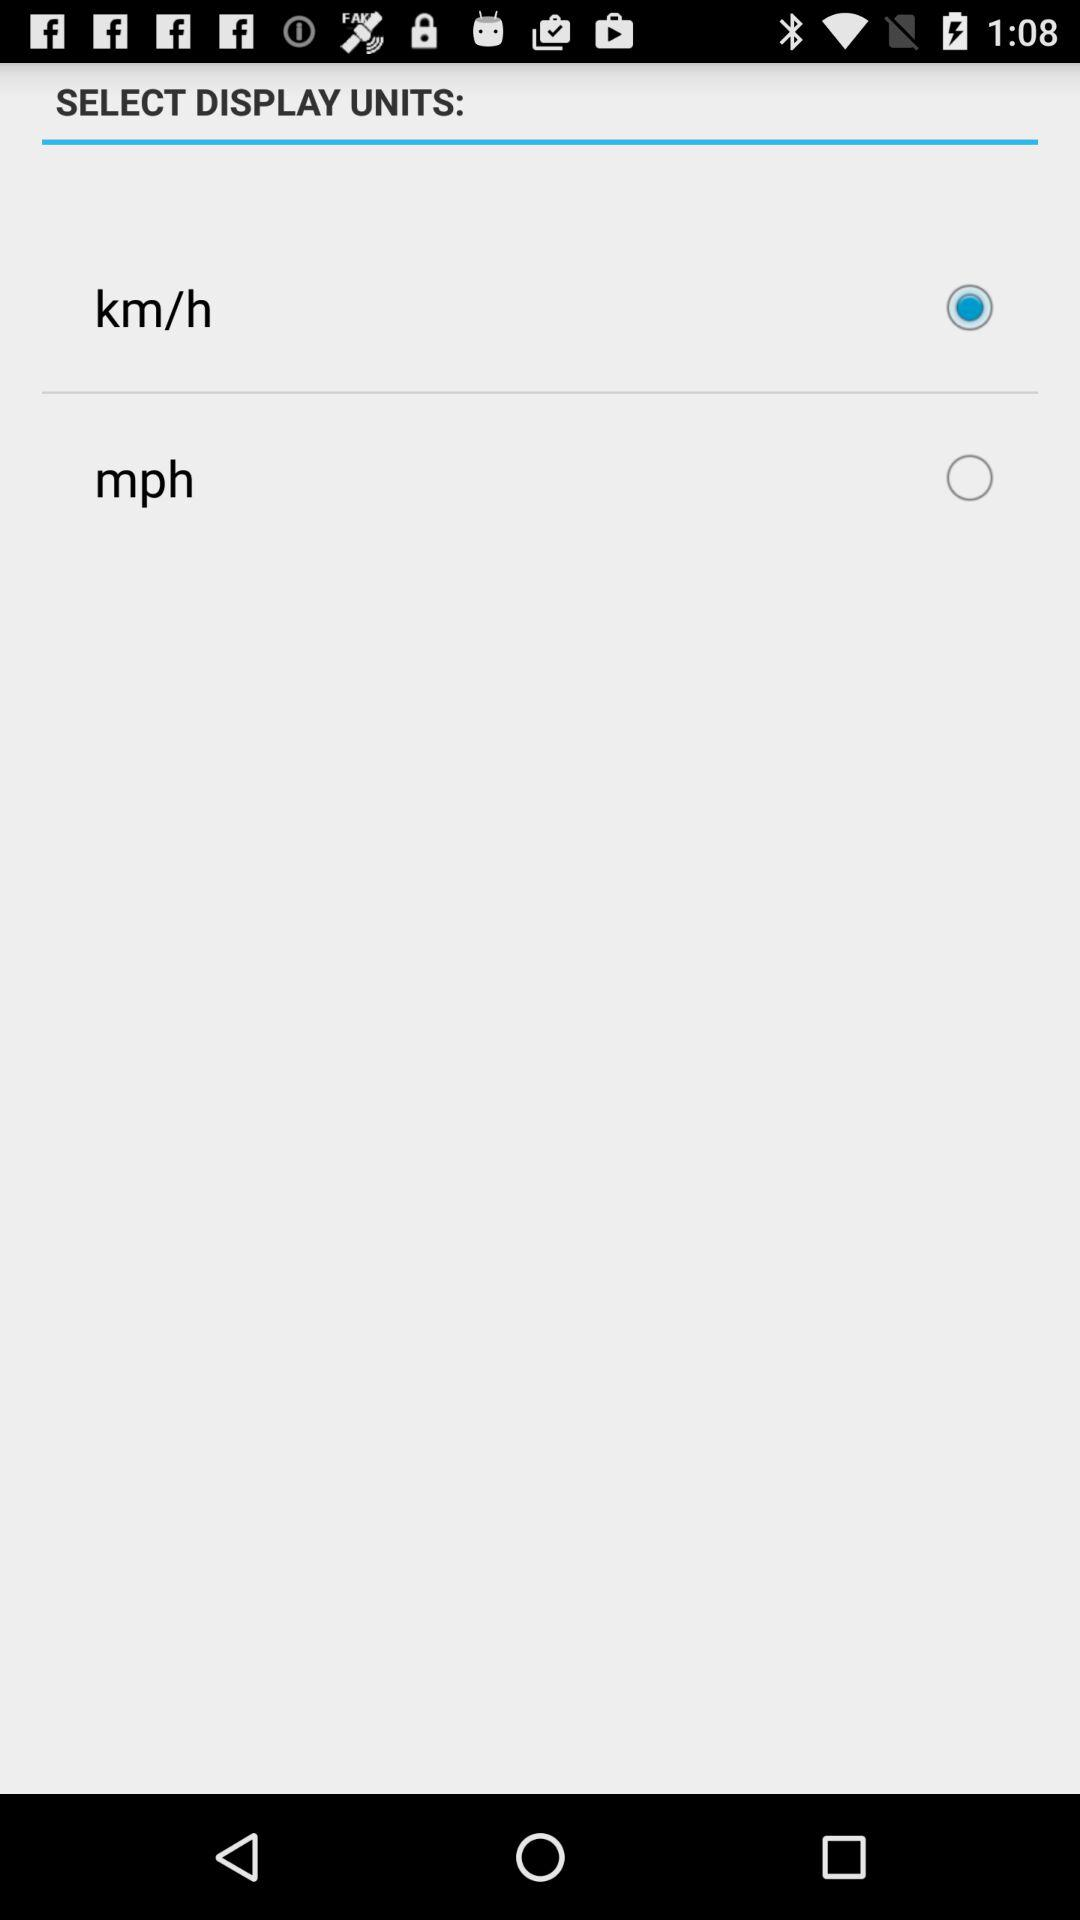Which unit is selected? The selected unit is kilometers per hour. 